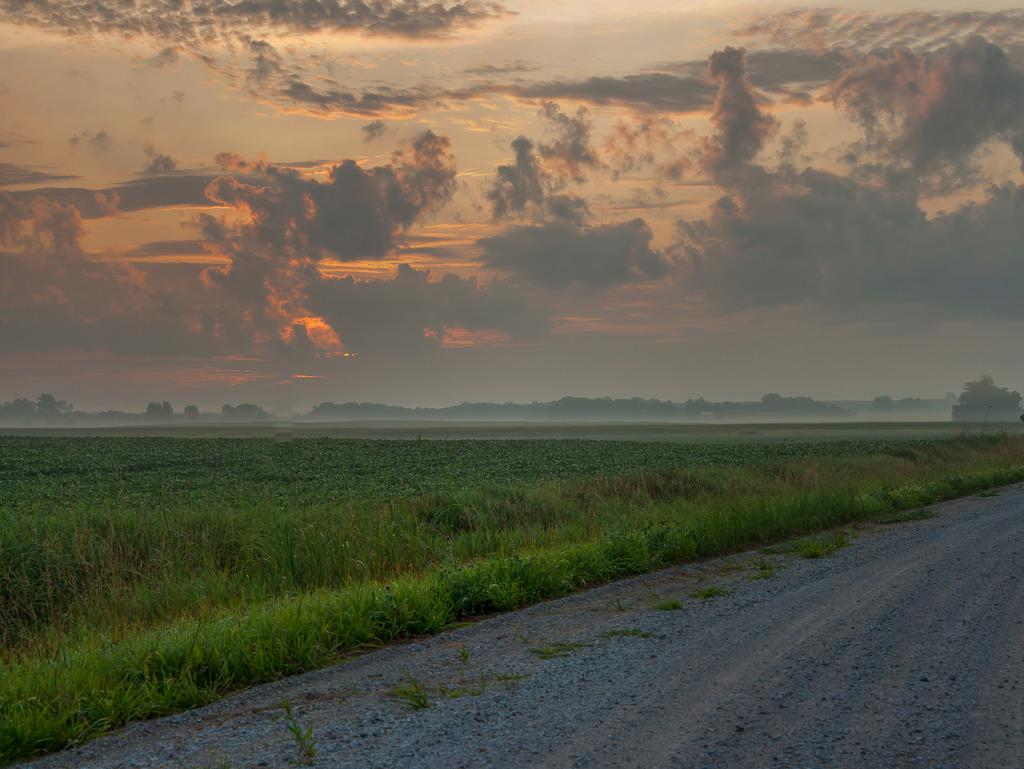What type of surface can be seen in the image? There is a road in the image. What type of vegetation is visible in the image? There is grass visible in the image. What can be seen in the background of the image? There are trees and the sky visible in the background of the image. What type of ship can be seen sailing in the grass in the image? There is no ship present in the image; it features a road, grass, trees, and the sky. How does the coach affect the temperature of the grass in the image? There is no coach present in the image, so it cannot affect the temperature of the grass. 